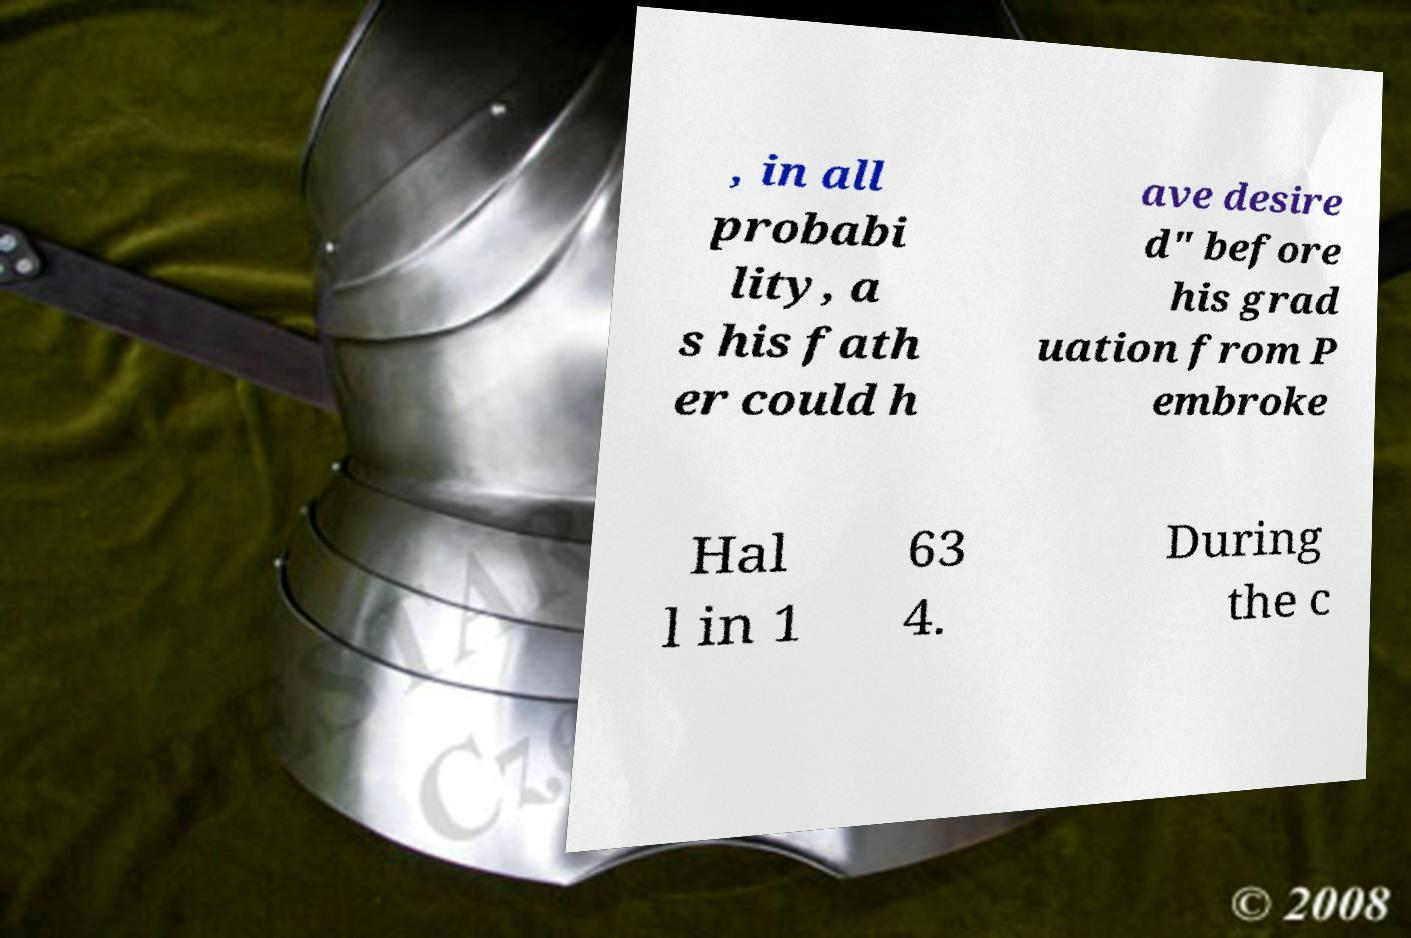Can you read and provide the text displayed in the image?This photo seems to have some interesting text. Can you extract and type it out for me? , in all probabi lity, a s his fath er could h ave desire d" before his grad uation from P embroke Hal l in 1 63 4. During the c 